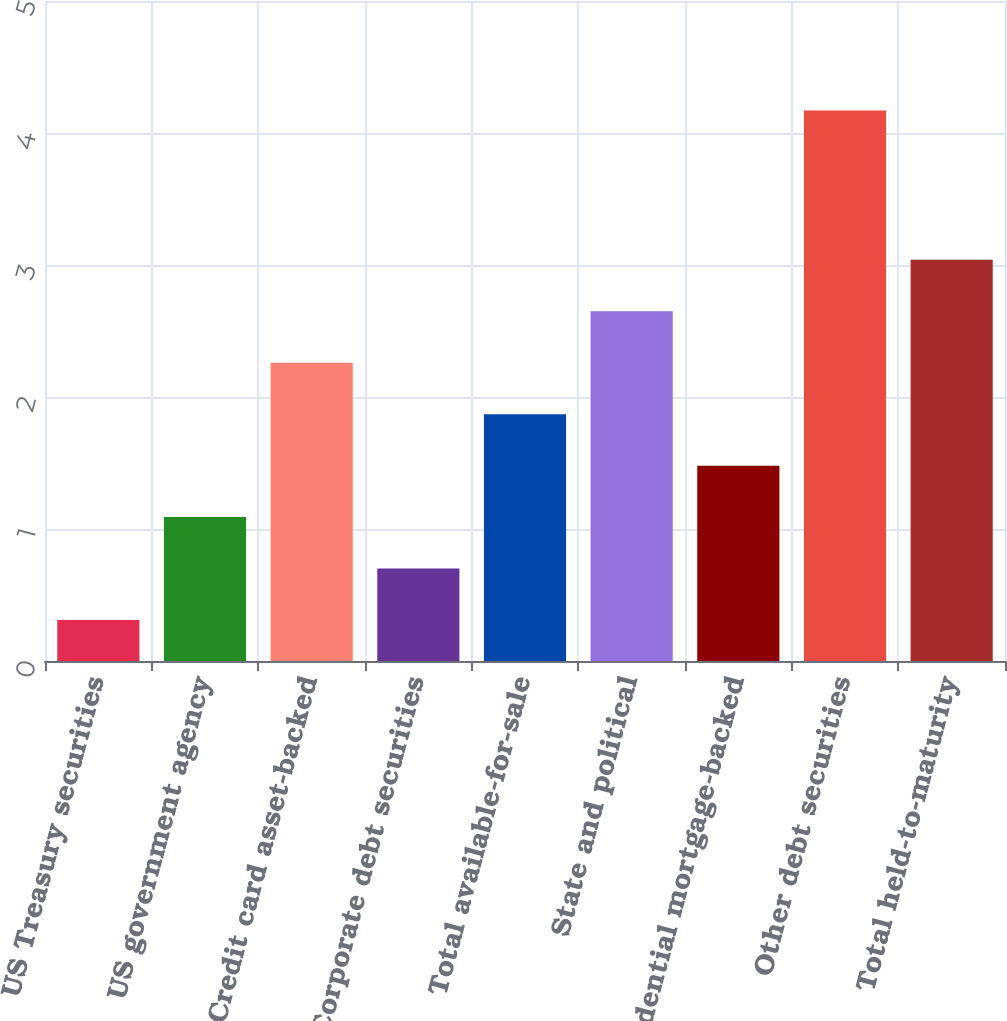Convert chart to OTSL. <chart><loc_0><loc_0><loc_500><loc_500><bar_chart><fcel>US Treasury securities<fcel>US government agency<fcel>Credit card asset-backed<fcel>Corporate debt securities<fcel>Total available-for-sale<fcel>State and political<fcel>Residential mortgage-backed<fcel>Other debt securities<fcel>Total held-to-maturity<nl><fcel>0.31<fcel>1.09<fcel>2.26<fcel>0.7<fcel>1.87<fcel>2.65<fcel>1.48<fcel>4.17<fcel>3.04<nl></chart> 